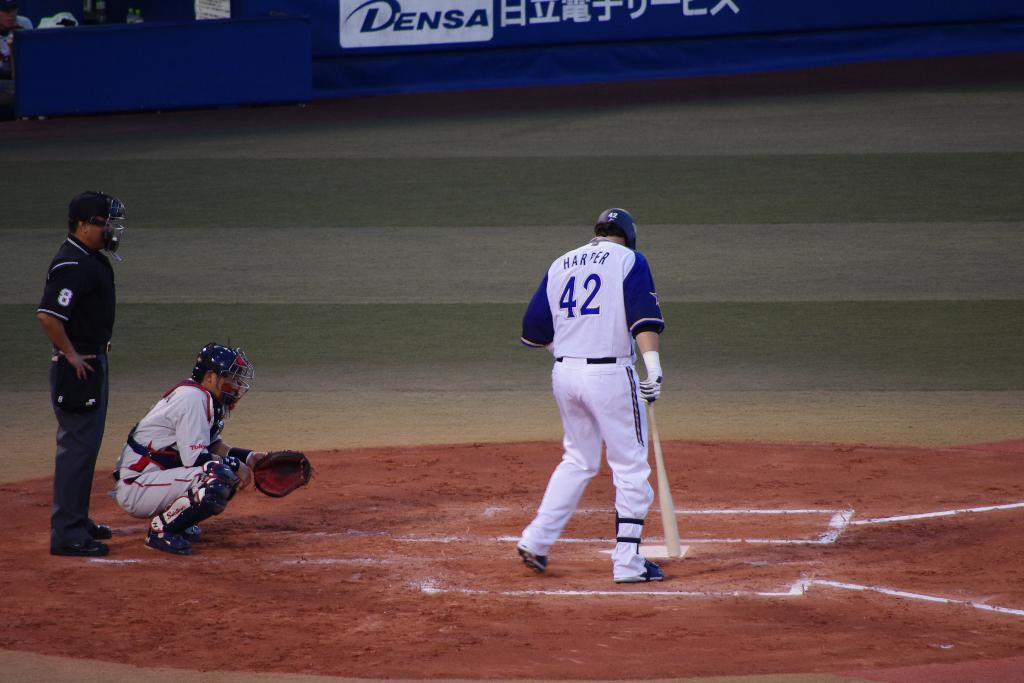<image>
Relay a brief, clear account of the picture shown. The player at bat is wearing number 42 